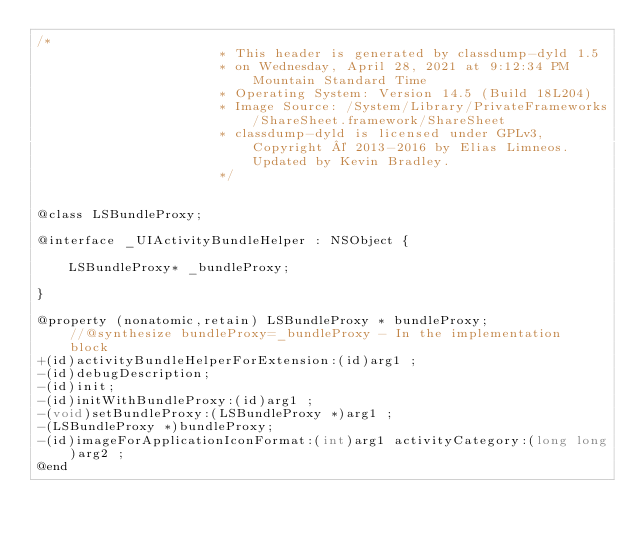Convert code to text. <code><loc_0><loc_0><loc_500><loc_500><_C_>/*
                       * This header is generated by classdump-dyld 1.5
                       * on Wednesday, April 28, 2021 at 9:12:34 PM Mountain Standard Time
                       * Operating System: Version 14.5 (Build 18L204)
                       * Image Source: /System/Library/PrivateFrameworks/ShareSheet.framework/ShareSheet
                       * classdump-dyld is licensed under GPLv3, Copyright © 2013-2016 by Elias Limneos. Updated by Kevin Bradley.
                       */


@class LSBundleProxy;

@interface _UIActivityBundleHelper : NSObject {

	LSBundleProxy* _bundleProxy;

}

@property (nonatomic,retain) LSBundleProxy * bundleProxy;              //@synthesize bundleProxy=_bundleProxy - In the implementation block
+(id)activityBundleHelperForExtension:(id)arg1 ;
-(id)debugDescription;
-(id)init;
-(id)initWithBundleProxy:(id)arg1 ;
-(void)setBundleProxy:(LSBundleProxy *)arg1 ;
-(LSBundleProxy *)bundleProxy;
-(id)imageForApplicationIconFormat:(int)arg1 activityCategory:(long long)arg2 ;
@end

</code> 